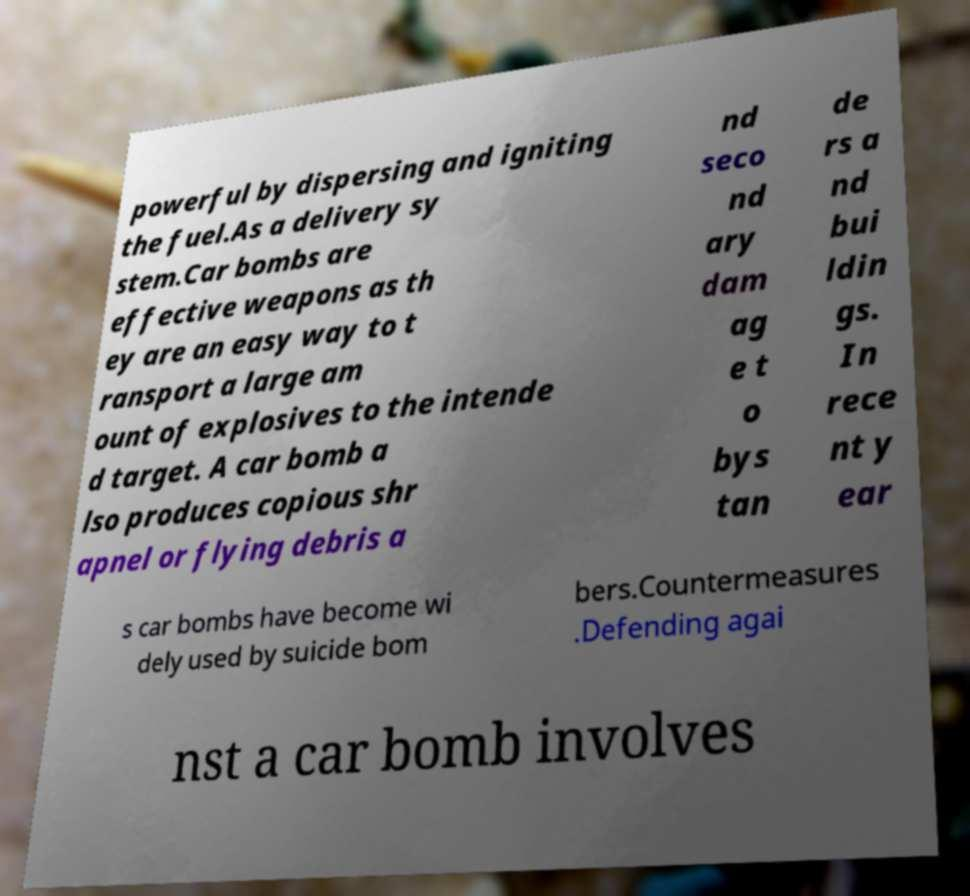What messages or text are displayed in this image? I need them in a readable, typed format. powerful by dispersing and igniting the fuel.As a delivery sy stem.Car bombs are effective weapons as th ey are an easy way to t ransport a large am ount of explosives to the intende d target. A car bomb a lso produces copious shr apnel or flying debris a nd seco nd ary dam ag e t o bys tan de rs a nd bui ldin gs. In rece nt y ear s car bombs have become wi dely used by suicide bom bers.Countermeasures .Defending agai nst a car bomb involves 